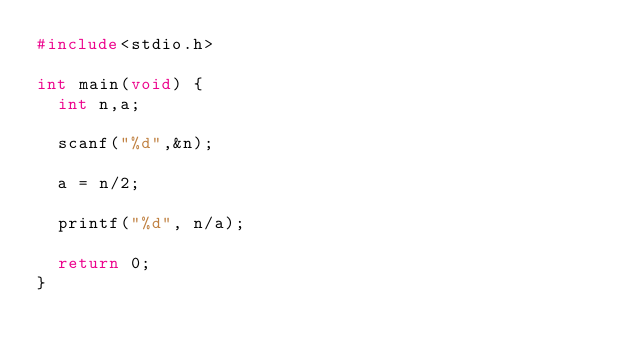<code> <loc_0><loc_0><loc_500><loc_500><_C_>#include<stdio.h>

int main(void) {
  int n,a;
  
  scanf("%d",&n);
  
  a = n/2;
  
  printf("%d", n/a);
  
  return 0;
}</code> 